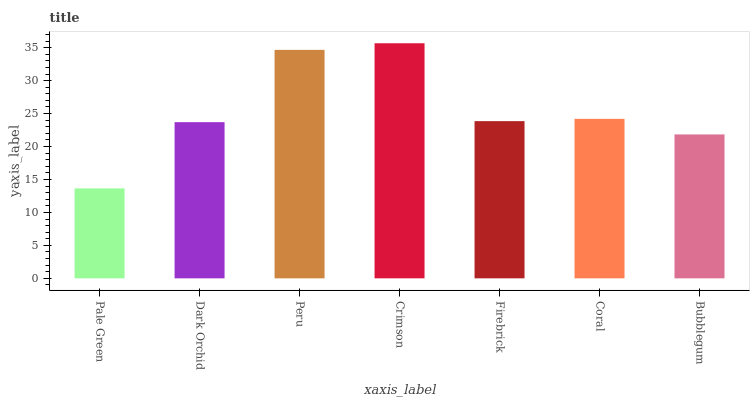Is Pale Green the minimum?
Answer yes or no. Yes. Is Crimson the maximum?
Answer yes or no. Yes. Is Dark Orchid the minimum?
Answer yes or no. No. Is Dark Orchid the maximum?
Answer yes or no. No. Is Dark Orchid greater than Pale Green?
Answer yes or no. Yes. Is Pale Green less than Dark Orchid?
Answer yes or no. Yes. Is Pale Green greater than Dark Orchid?
Answer yes or no. No. Is Dark Orchid less than Pale Green?
Answer yes or no. No. Is Firebrick the high median?
Answer yes or no. Yes. Is Firebrick the low median?
Answer yes or no. Yes. Is Coral the high median?
Answer yes or no. No. Is Pale Green the low median?
Answer yes or no. No. 